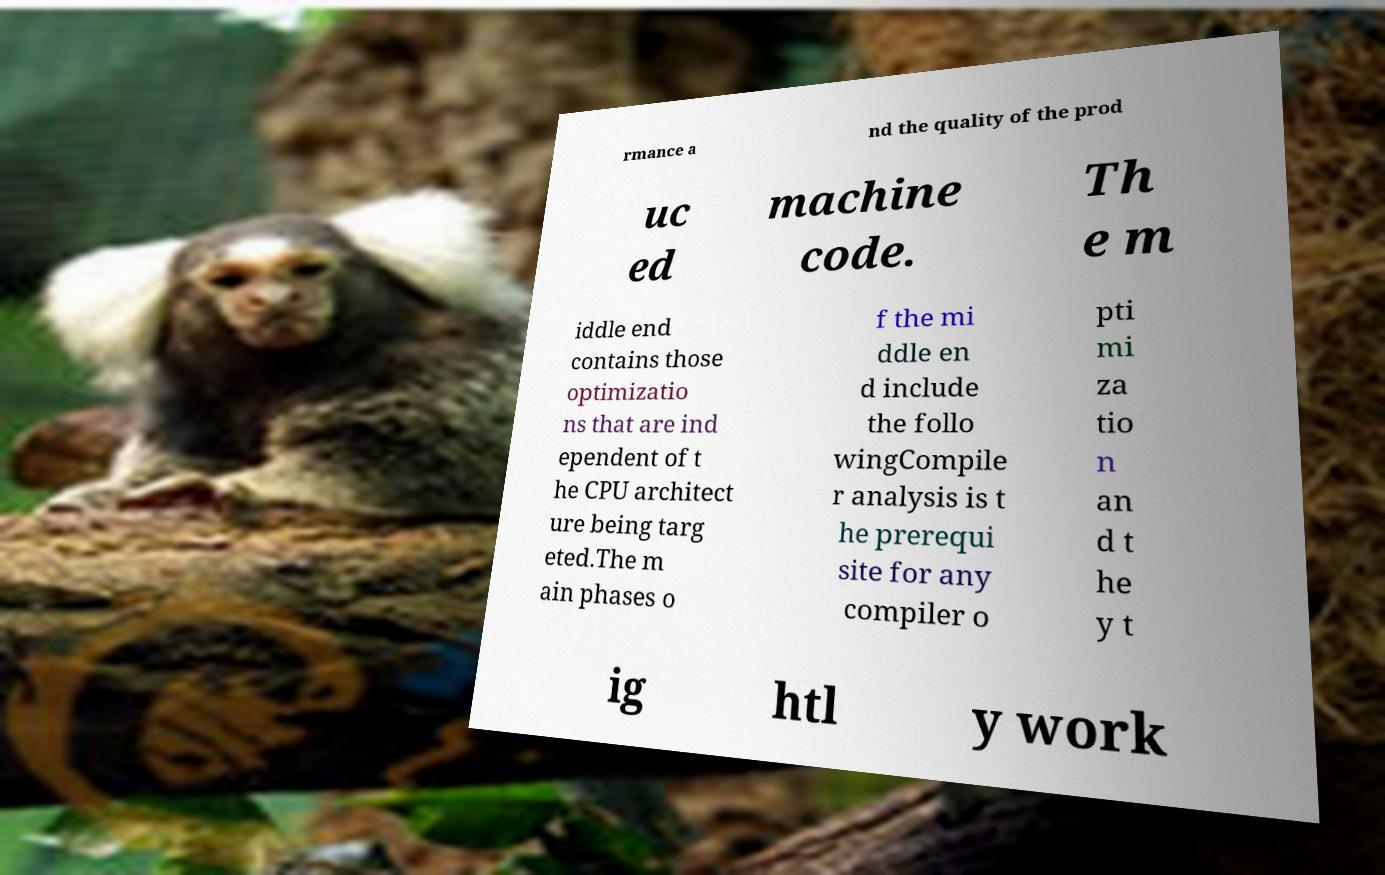For documentation purposes, I need the text within this image transcribed. Could you provide that? rmance a nd the quality of the prod uc ed machine code. Th e m iddle end contains those optimizatio ns that are ind ependent of t he CPU architect ure being targ eted.The m ain phases o f the mi ddle en d include the follo wingCompile r analysis is t he prerequi site for any compiler o pti mi za tio n an d t he y t ig htl y work 